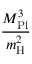<formula> <loc_0><loc_0><loc_500><loc_500>\frac { M _ { P l } ^ { 3 } } { m _ { H } ^ { 2 } }</formula> 